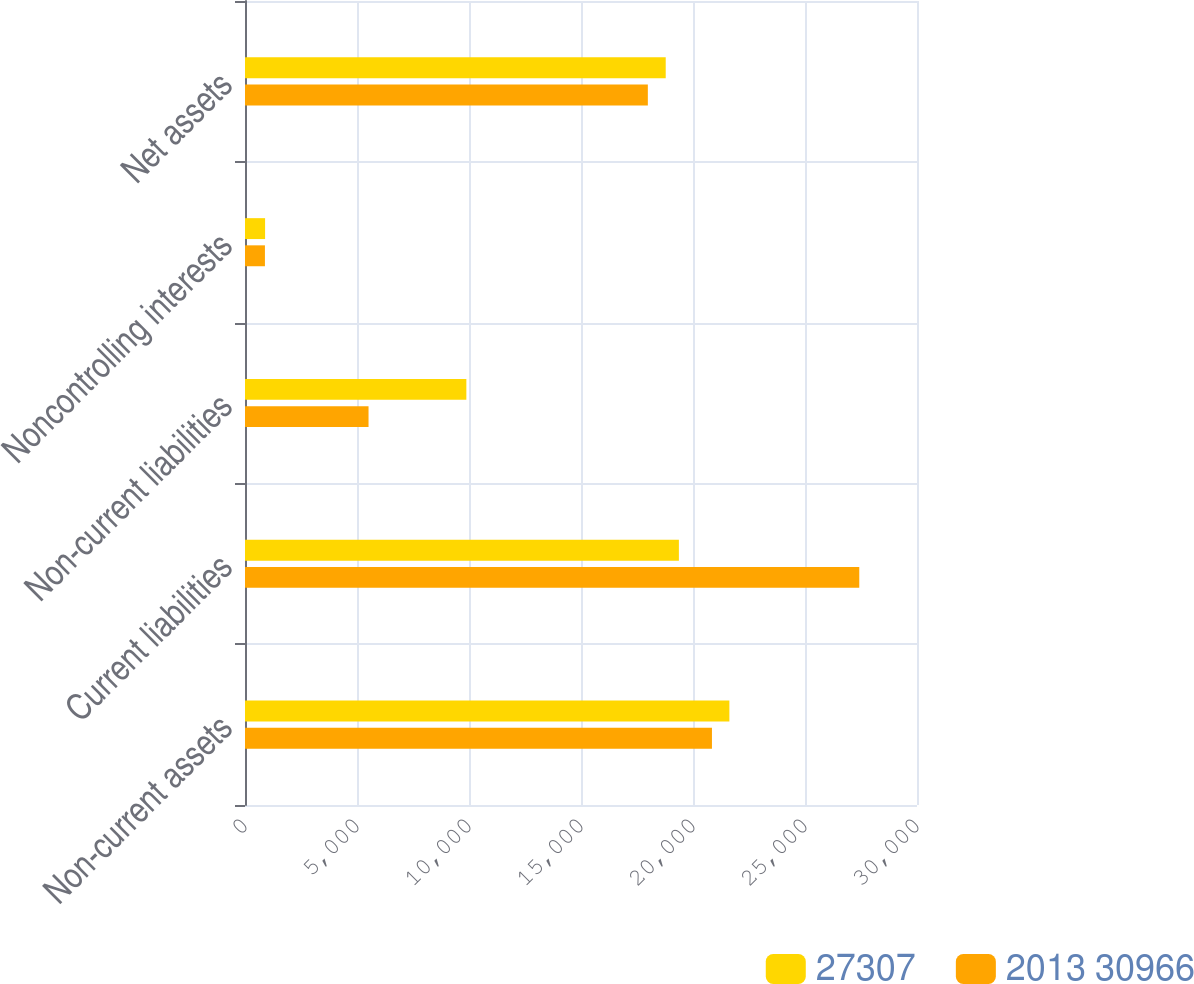Convert chart. <chart><loc_0><loc_0><loc_500><loc_500><stacked_bar_chart><ecel><fcel>Non-current assets<fcel>Current liabilities<fcel>Non-current liabilities<fcel>Noncontrolling interests<fcel>Net assets<nl><fcel>27307<fcel>21624<fcel>19370<fcel>9882<fcel>897<fcel>18782<nl><fcel>2013 30966<fcel>20846<fcel>27423<fcel>5515<fcel>890<fcel>17984<nl></chart> 